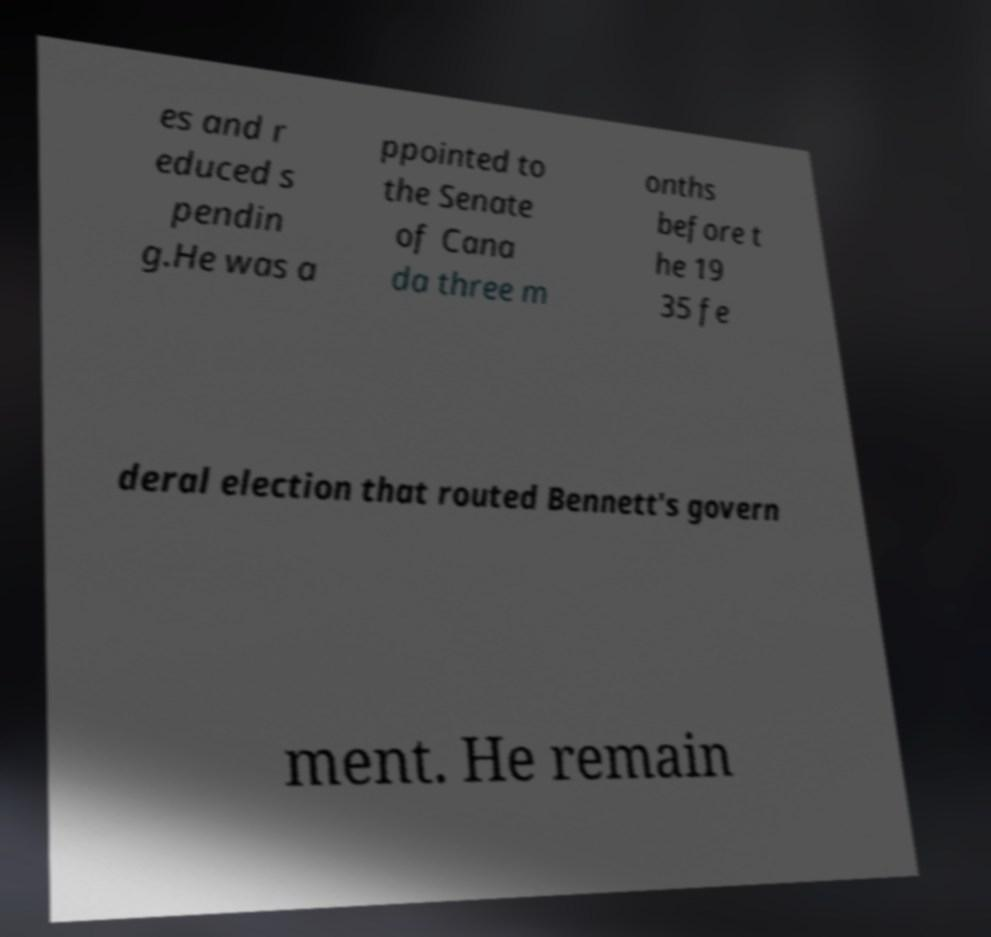Could you assist in decoding the text presented in this image and type it out clearly? es and r educed s pendin g.He was a ppointed to the Senate of Cana da three m onths before t he 19 35 fe deral election that routed Bennett's govern ment. He remain 